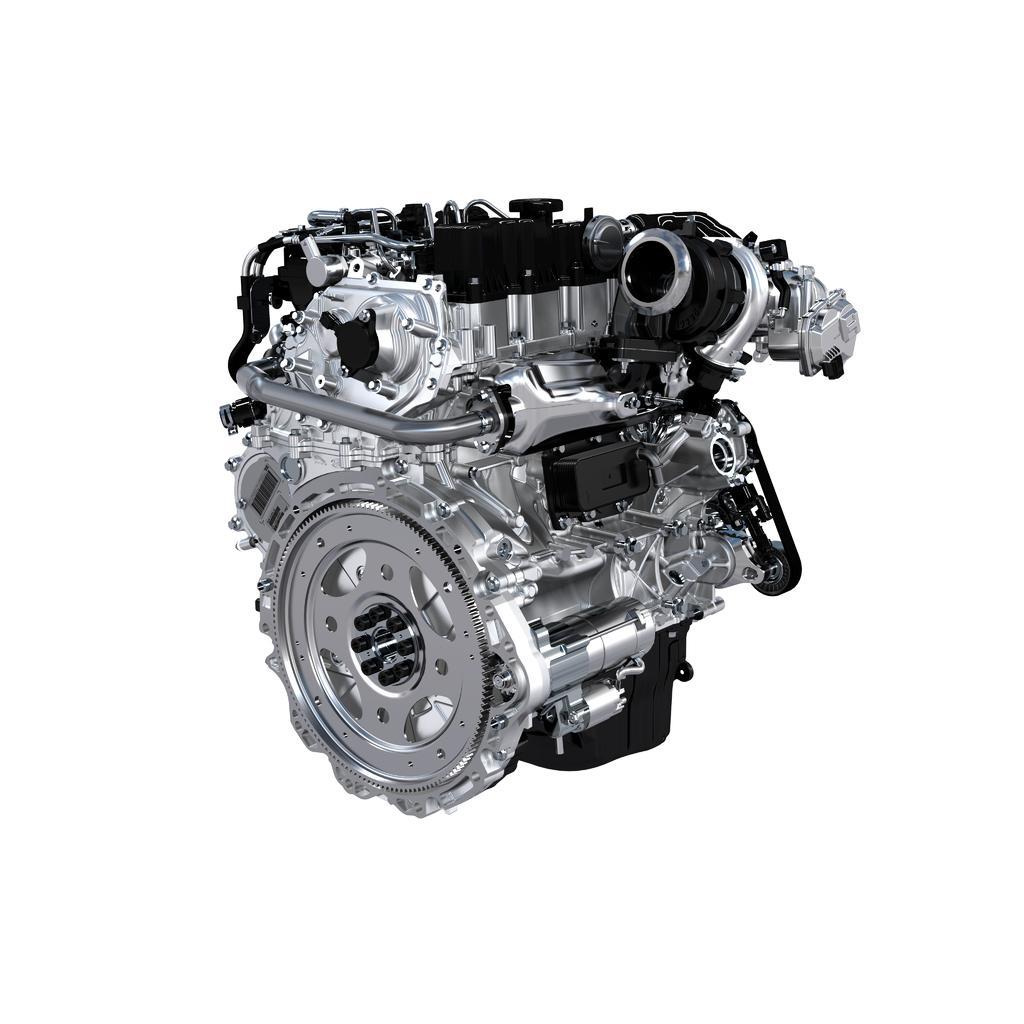Could you give a brief overview of what you see in this image? In this picture we can see a car engine, there is a white color background. 